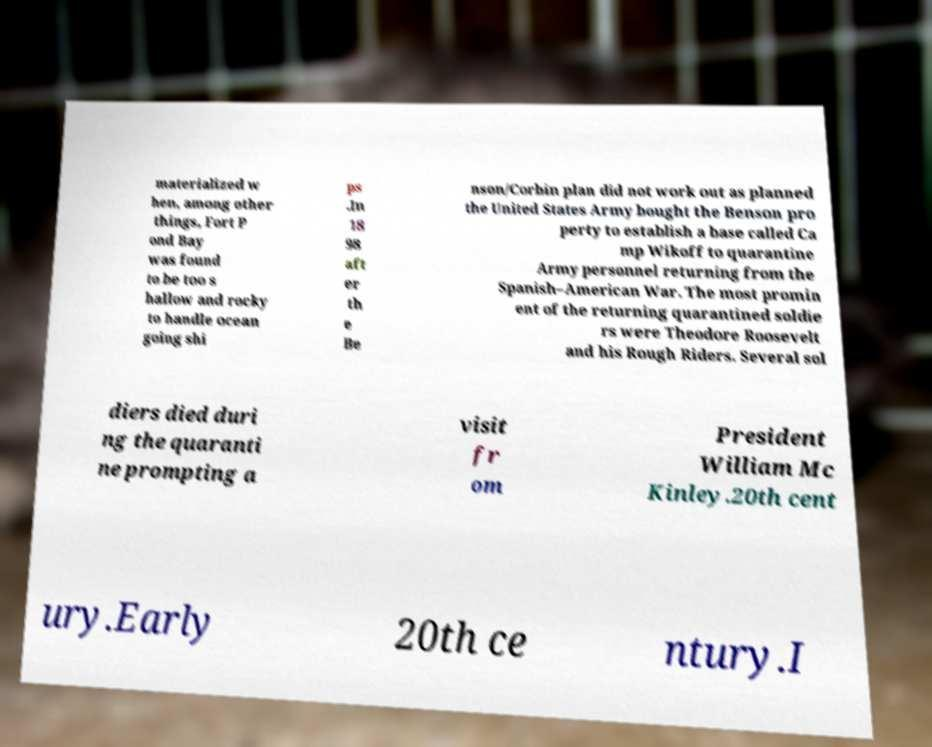Can you accurately transcribe the text from the provided image for me? materialized w hen, among other things, Fort P ond Bay was found to be too s hallow and rocky to handle ocean going shi ps .In 18 98 aft er th e Be nson/Corbin plan did not work out as planned the United States Army bought the Benson pro perty to establish a base called Ca mp Wikoff to quarantine Army personnel returning from the Spanish–American War. The most promin ent of the returning quarantined soldie rs were Theodore Roosevelt and his Rough Riders. Several sol diers died duri ng the quaranti ne prompting a visit fr om President William Mc Kinley.20th cent ury.Early 20th ce ntury.I 